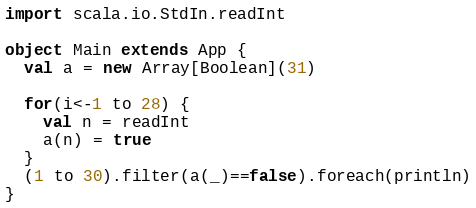<code> <loc_0><loc_0><loc_500><loc_500><_Scala_>import scala.io.StdIn.readInt

object Main extends App {
  val a = new Array[Boolean](31)

  for(i<-1 to 28) {
    val n = readInt
    a(n) = true
  }
  (1 to 30).filter(a(_)==false).foreach(println)
}</code> 